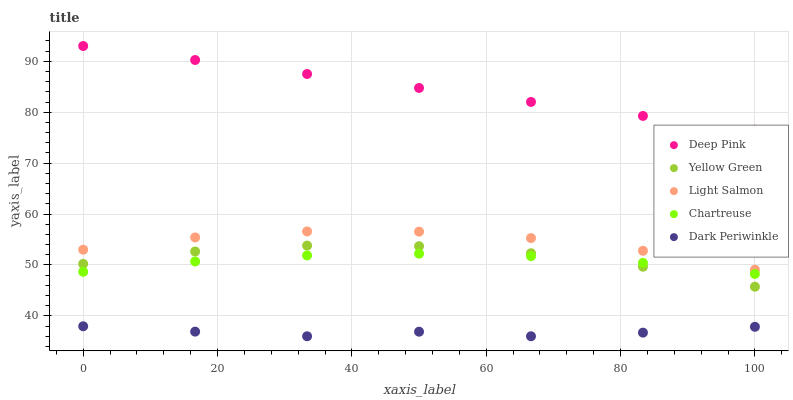Does Dark Periwinkle have the minimum area under the curve?
Answer yes or no. Yes. Does Deep Pink have the maximum area under the curve?
Answer yes or no. Yes. Does Yellow Green have the minimum area under the curve?
Answer yes or no. No. Does Yellow Green have the maximum area under the curve?
Answer yes or no. No. Is Deep Pink the smoothest?
Answer yes or no. Yes. Is Yellow Green the roughest?
Answer yes or no. Yes. Is Yellow Green the smoothest?
Answer yes or no. No. Is Deep Pink the roughest?
Answer yes or no. No. Does Dark Periwinkle have the lowest value?
Answer yes or no. Yes. Does Yellow Green have the lowest value?
Answer yes or no. No. Does Deep Pink have the highest value?
Answer yes or no. Yes. Does Yellow Green have the highest value?
Answer yes or no. No. Is Chartreuse less than Light Salmon?
Answer yes or no. Yes. Is Deep Pink greater than Chartreuse?
Answer yes or no. Yes. Does Yellow Green intersect Chartreuse?
Answer yes or no. Yes. Is Yellow Green less than Chartreuse?
Answer yes or no. No. Is Yellow Green greater than Chartreuse?
Answer yes or no. No. Does Chartreuse intersect Light Salmon?
Answer yes or no. No. 